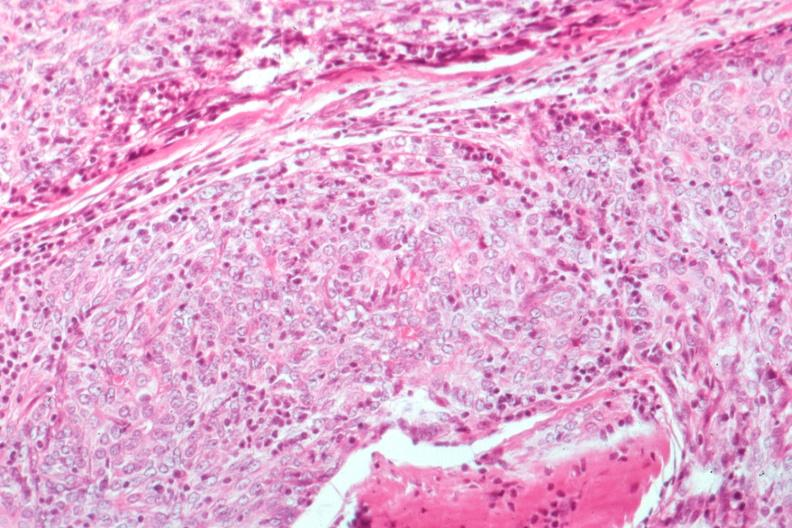what does this image show?
Answer the question using a single word or phrase. Epithelial lesion surgical path 